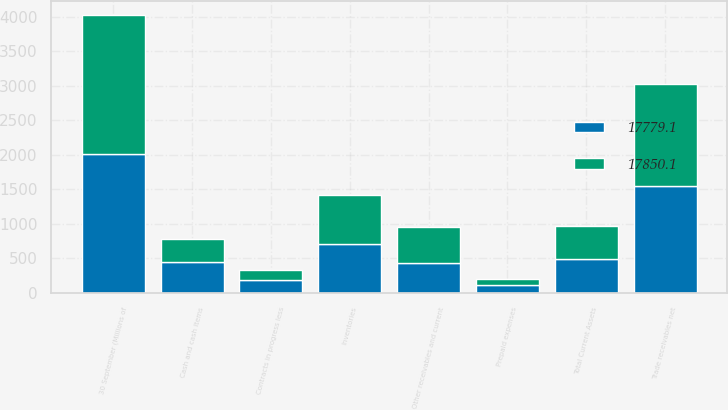Convert chart. <chart><loc_0><loc_0><loc_500><loc_500><stacked_bar_chart><ecel><fcel>30 September (Millions of<fcel>Cash and cash items<fcel>Trade receivables net<fcel>Inventories<fcel>Contracts in progress less<fcel>Prepaid expenses<fcel>Other receivables and current<fcel>Total Current Assets<nl><fcel>17850.1<fcel>2014<fcel>336.6<fcel>1486<fcel>706<fcel>155.4<fcel>87.8<fcel>523<fcel>486.7<nl><fcel>17779.1<fcel>2013<fcel>450.4<fcel>1544.3<fcel>706.1<fcel>182.3<fcel>121.1<fcel>432.4<fcel>486.7<nl></chart> 